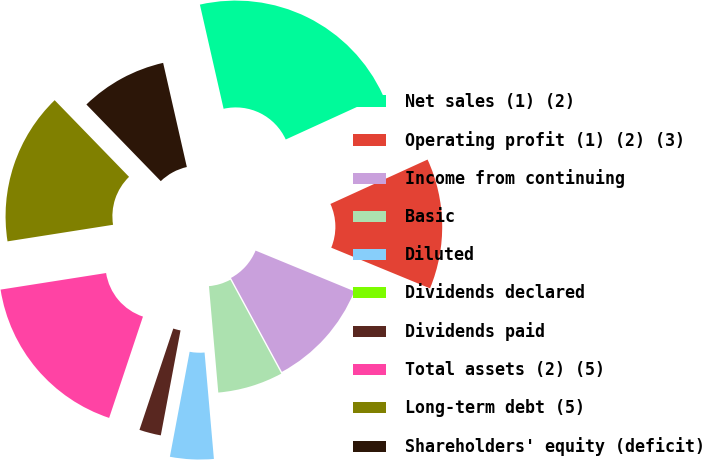Convert chart. <chart><loc_0><loc_0><loc_500><loc_500><pie_chart><fcel>Net sales (1) (2)<fcel>Operating profit (1) (2) (3)<fcel>Income from continuing<fcel>Basic<fcel>Diluted<fcel>Dividends declared<fcel>Dividends paid<fcel>Total assets (2) (5)<fcel>Long-term debt (5)<fcel>Shareholders' equity (deficit)<nl><fcel>21.74%<fcel>13.04%<fcel>10.87%<fcel>6.52%<fcel>4.35%<fcel>0.0%<fcel>2.17%<fcel>17.39%<fcel>15.22%<fcel>8.7%<nl></chart> 